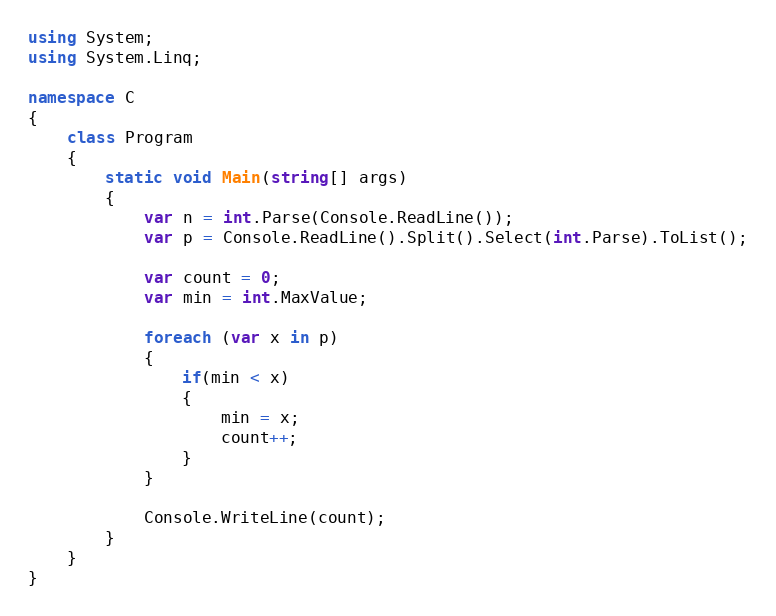<code> <loc_0><loc_0><loc_500><loc_500><_C#_>using System;
using System.Linq;

namespace C
{
    class Program
    {
        static void Main(string[] args)
        {
            var n = int.Parse(Console.ReadLine());
            var p = Console.ReadLine().Split().Select(int.Parse).ToList();

            var count = 0;
            var min = int.MaxValue;

            foreach (var x in p)
            {
                if(min < x)
                {
                    min = x;
                    count++;
                }
            }

            Console.WriteLine(count);
        }
    }
}
</code> 